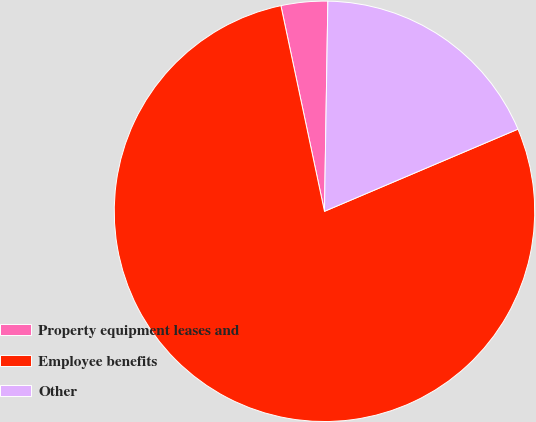Convert chart to OTSL. <chart><loc_0><loc_0><loc_500><loc_500><pie_chart><fcel>Property equipment leases and<fcel>Employee benefits<fcel>Other<nl><fcel>3.58%<fcel>78.07%<fcel>18.35%<nl></chart> 